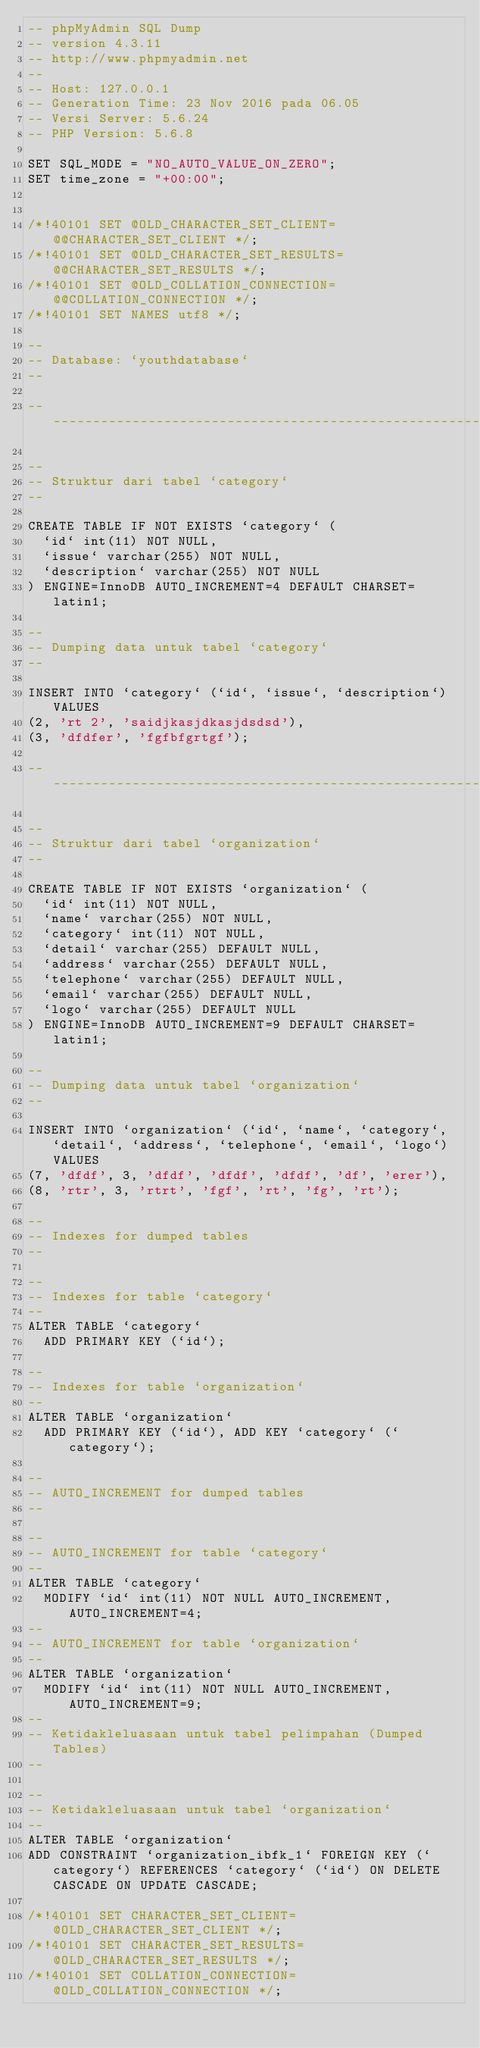Convert code to text. <code><loc_0><loc_0><loc_500><loc_500><_SQL_>-- phpMyAdmin SQL Dump
-- version 4.3.11
-- http://www.phpmyadmin.net
--
-- Host: 127.0.0.1
-- Generation Time: 23 Nov 2016 pada 06.05
-- Versi Server: 5.6.24
-- PHP Version: 5.6.8

SET SQL_MODE = "NO_AUTO_VALUE_ON_ZERO";
SET time_zone = "+00:00";


/*!40101 SET @OLD_CHARACTER_SET_CLIENT=@@CHARACTER_SET_CLIENT */;
/*!40101 SET @OLD_CHARACTER_SET_RESULTS=@@CHARACTER_SET_RESULTS */;
/*!40101 SET @OLD_COLLATION_CONNECTION=@@COLLATION_CONNECTION */;
/*!40101 SET NAMES utf8 */;

--
-- Database: `youthdatabase`
--

-- --------------------------------------------------------

--
-- Struktur dari tabel `category`
--

CREATE TABLE IF NOT EXISTS `category` (
  `id` int(11) NOT NULL,
  `issue` varchar(255) NOT NULL,
  `description` varchar(255) NOT NULL
) ENGINE=InnoDB AUTO_INCREMENT=4 DEFAULT CHARSET=latin1;

--
-- Dumping data untuk tabel `category`
--

INSERT INTO `category` (`id`, `issue`, `description`) VALUES
(2, 'rt 2', 'saidjkasjdkasjdsdsd'),
(3, 'dfdfer', 'fgfbfgrtgf');

-- --------------------------------------------------------

--
-- Struktur dari tabel `organization`
--

CREATE TABLE IF NOT EXISTS `organization` (
  `id` int(11) NOT NULL,
  `name` varchar(255) NOT NULL,
  `category` int(11) NOT NULL,
  `detail` varchar(255) DEFAULT NULL,
  `address` varchar(255) DEFAULT NULL,
  `telephone` varchar(255) DEFAULT NULL,
  `email` varchar(255) DEFAULT NULL,
  `logo` varchar(255) DEFAULT NULL
) ENGINE=InnoDB AUTO_INCREMENT=9 DEFAULT CHARSET=latin1;

--
-- Dumping data untuk tabel `organization`
--

INSERT INTO `organization` (`id`, `name`, `category`, `detail`, `address`, `telephone`, `email`, `logo`) VALUES
(7, 'dfdf', 3, 'dfdf', 'dfdf', 'dfdf', 'df', 'erer'),
(8, 'rtr', 3, 'rtrt', 'fgf', 'rt', 'fg', 'rt');

--
-- Indexes for dumped tables
--

--
-- Indexes for table `category`
--
ALTER TABLE `category`
  ADD PRIMARY KEY (`id`);

--
-- Indexes for table `organization`
--
ALTER TABLE `organization`
  ADD PRIMARY KEY (`id`), ADD KEY `category` (`category`);

--
-- AUTO_INCREMENT for dumped tables
--

--
-- AUTO_INCREMENT for table `category`
--
ALTER TABLE `category`
  MODIFY `id` int(11) NOT NULL AUTO_INCREMENT,AUTO_INCREMENT=4;
--
-- AUTO_INCREMENT for table `organization`
--
ALTER TABLE `organization`
  MODIFY `id` int(11) NOT NULL AUTO_INCREMENT,AUTO_INCREMENT=9;
--
-- Ketidakleluasaan untuk tabel pelimpahan (Dumped Tables)
--

--
-- Ketidakleluasaan untuk tabel `organization`
--
ALTER TABLE `organization`
ADD CONSTRAINT `organization_ibfk_1` FOREIGN KEY (`category`) REFERENCES `category` (`id`) ON DELETE CASCADE ON UPDATE CASCADE;

/*!40101 SET CHARACTER_SET_CLIENT=@OLD_CHARACTER_SET_CLIENT */;
/*!40101 SET CHARACTER_SET_RESULTS=@OLD_CHARACTER_SET_RESULTS */;
/*!40101 SET COLLATION_CONNECTION=@OLD_COLLATION_CONNECTION */;
</code> 